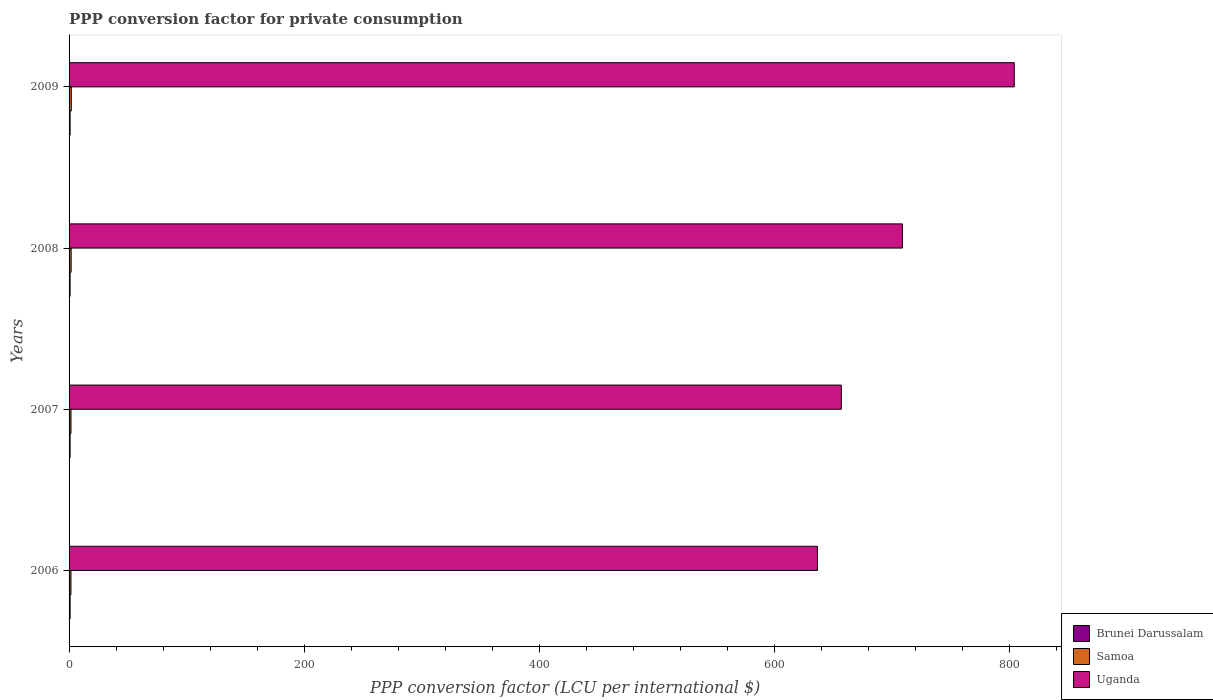How many different coloured bars are there?
Offer a very short reply. 3. Are the number of bars per tick equal to the number of legend labels?
Your answer should be very brief. Yes. How many bars are there on the 1st tick from the bottom?
Give a very brief answer. 3. What is the label of the 2nd group of bars from the top?
Your answer should be very brief. 2008. In how many cases, is the number of bars for a given year not equal to the number of legend labels?
Your answer should be compact. 0. What is the PPP conversion factor for private consumption in Uganda in 2006?
Give a very brief answer. 636.94. Across all years, what is the maximum PPP conversion factor for private consumption in Samoa?
Your response must be concise. 1.88. Across all years, what is the minimum PPP conversion factor for private consumption in Brunei Darussalam?
Ensure brevity in your answer.  0.86. In which year was the PPP conversion factor for private consumption in Samoa maximum?
Make the answer very short. 2009. In which year was the PPP conversion factor for private consumption in Samoa minimum?
Offer a very short reply. 2006. What is the total PPP conversion factor for private consumption in Brunei Darussalam in the graph?
Your response must be concise. 3.5. What is the difference between the PPP conversion factor for private consumption in Brunei Darussalam in 2006 and that in 2009?
Make the answer very short. 0.02. What is the difference between the PPP conversion factor for private consumption in Uganda in 2006 and the PPP conversion factor for private consumption in Brunei Darussalam in 2007?
Give a very brief answer. 636.06. What is the average PPP conversion factor for private consumption in Uganda per year?
Provide a succinct answer. 701.99. In the year 2009, what is the difference between the PPP conversion factor for private consumption in Uganda and PPP conversion factor for private consumption in Samoa?
Offer a very short reply. 802.58. What is the ratio of the PPP conversion factor for private consumption in Samoa in 2006 to that in 2009?
Offer a very short reply. 0.85. What is the difference between the highest and the second highest PPP conversion factor for private consumption in Uganda?
Ensure brevity in your answer.  95.19. What is the difference between the highest and the lowest PPP conversion factor for private consumption in Uganda?
Keep it short and to the point. 167.52. In how many years, is the PPP conversion factor for private consumption in Samoa greater than the average PPP conversion factor for private consumption in Samoa taken over all years?
Provide a short and direct response. 2. Is the sum of the PPP conversion factor for private consumption in Samoa in 2006 and 2008 greater than the maximum PPP conversion factor for private consumption in Uganda across all years?
Ensure brevity in your answer.  No. What does the 3rd bar from the top in 2007 represents?
Keep it short and to the point. Brunei Darussalam. What does the 1st bar from the bottom in 2008 represents?
Give a very brief answer. Brunei Darussalam. Is it the case that in every year, the sum of the PPP conversion factor for private consumption in Brunei Darussalam and PPP conversion factor for private consumption in Samoa is greater than the PPP conversion factor for private consumption in Uganda?
Keep it short and to the point. No. How many bars are there?
Your answer should be compact. 12. How many years are there in the graph?
Offer a very short reply. 4. What is the difference between two consecutive major ticks on the X-axis?
Make the answer very short. 200. Does the graph contain any zero values?
Your answer should be very brief. No. Where does the legend appear in the graph?
Give a very brief answer. Bottom right. How are the legend labels stacked?
Give a very brief answer. Vertical. What is the title of the graph?
Give a very brief answer. PPP conversion factor for private consumption. Does "Ethiopia" appear as one of the legend labels in the graph?
Make the answer very short. No. What is the label or title of the X-axis?
Make the answer very short. PPP conversion factor (LCU per international $). What is the label or title of the Y-axis?
Provide a succinct answer. Years. What is the PPP conversion factor (LCU per international $) in Brunei Darussalam in 2006?
Keep it short and to the point. 0.89. What is the PPP conversion factor (LCU per international $) in Samoa in 2006?
Give a very brief answer. 1.6. What is the PPP conversion factor (LCU per international $) in Uganda in 2006?
Ensure brevity in your answer.  636.94. What is the PPP conversion factor (LCU per international $) in Brunei Darussalam in 2007?
Your response must be concise. 0.88. What is the PPP conversion factor (LCU per international $) in Samoa in 2007?
Your answer should be compact. 1.64. What is the PPP conversion factor (LCU per international $) of Uganda in 2007?
Keep it short and to the point. 657.29. What is the PPP conversion factor (LCU per international $) in Brunei Darussalam in 2008?
Offer a terse response. 0.86. What is the PPP conversion factor (LCU per international $) in Samoa in 2008?
Your response must be concise. 1.76. What is the PPP conversion factor (LCU per international $) of Uganda in 2008?
Keep it short and to the point. 709.27. What is the PPP conversion factor (LCU per international $) in Brunei Darussalam in 2009?
Ensure brevity in your answer.  0.87. What is the PPP conversion factor (LCU per international $) of Samoa in 2009?
Your answer should be compact. 1.88. What is the PPP conversion factor (LCU per international $) in Uganda in 2009?
Give a very brief answer. 804.46. Across all years, what is the maximum PPP conversion factor (LCU per international $) in Brunei Darussalam?
Ensure brevity in your answer.  0.89. Across all years, what is the maximum PPP conversion factor (LCU per international $) of Samoa?
Your answer should be very brief. 1.88. Across all years, what is the maximum PPP conversion factor (LCU per international $) in Uganda?
Give a very brief answer. 804.46. Across all years, what is the minimum PPP conversion factor (LCU per international $) in Brunei Darussalam?
Your answer should be very brief. 0.86. Across all years, what is the minimum PPP conversion factor (LCU per international $) in Samoa?
Provide a succinct answer. 1.6. Across all years, what is the minimum PPP conversion factor (LCU per international $) of Uganda?
Your response must be concise. 636.94. What is the total PPP conversion factor (LCU per international $) of Brunei Darussalam in the graph?
Keep it short and to the point. 3.5. What is the total PPP conversion factor (LCU per international $) of Samoa in the graph?
Keep it short and to the point. 6.88. What is the total PPP conversion factor (LCU per international $) of Uganda in the graph?
Provide a short and direct response. 2807.96. What is the difference between the PPP conversion factor (LCU per international $) in Brunei Darussalam in 2006 and that in 2007?
Offer a terse response. 0.02. What is the difference between the PPP conversion factor (LCU per international $) in Samoa in 2006 and that in 2007?
Offer a very short reply. -0.04. What is the difference between the PPP conversion factor (LCU per international $) of Uganda in 2006 and that in 2007?
Your response must be concise. -20.35. What is the difference between the PPP conversion factor (LCU per international $) of Brunei Darussalam in 2006 and that in 2008?
Offer a very short reply. 0.03. What is the difference between the PPP conversion factor (LCU per international $) in Samoa in 2006 and that in 2008?
Your answer should be compact. -0.16. What is the difference between the PPP conversion factor (LCU per international $) of Uganda in 2006 and that in 2008?
Keep it short and to the point. -72.33. What is the difference between the PPP conversion factor (LCU per international $) in Brunei Darussalam in 2006 and that in 2009?
Your answer should be compact. 0.02. What is the difference between the PPP conversion factor (LCU per international $) of Samoa in 2006 and that in 2009?
Ensure brevity in your answer.  -0.28. What is the difference between the PPP conversion factor (LCU per international $) of Uganda in 2006 and that in 2009?
Offer a terse response. -167.52. What is the difference between the PPP conversion factor (LCU per international $) of Brunei Darussalam in 2007 and that in 2008?
Offer a very short reply. 0.01. What is the difference between the PPP conversion factor (LCU per international $) of Samoa in 2007 and that in 2008?
Keep it short and to the point. -0.12. What is the difference between the PPP conversion factor (LCU per international $) in Uganda in 2007 and that in 2008?
Your answer should be very brief. -51.98. What is the difference between the PPP conversion factor (LCU per international $) in Brunei Darussalam in 2007 and that in 2009?
Your answer should be very brief. 0. What is the difference between the PPP conversion factor (LCU per international $) in Samoa in 2007 and that in 2009?
Make the answer very short. -0.24. What is the difference between the PPP conversion factor (LCU per international $) in Uganda in 2007 and that in 2009?
Your answer should be compact. -147.17. What is the difference between the PPP conversion factor (LCU per international $) of Brunei Darussalam in 2008 and that in 2009?
Provide a succinct answer. -0.01. What is the difference between the PPP conversion factor (LCU per international $) of Samoa in 2008 and that in 2009?
Your response must be concise. -0.12. What is the difference between the PPP conversion factor (LCU per international $) of Uganda in 2008 and that in 2009?
Provide a succinct answer. -95.19. What is the difference between the PPP conversion factor (LCU per international $) of Brunei Darussalam in 2006 and the PPP conversion factor (LCU per international $) of Samoa in 2007?
Keep it short and to the point. -0.75. What is the difference between the PPP conversion factor (LCU per international $) in Brunei Darussalam in 2006 and the PPP conversion factor (LCU per international $) in Uganda in 2007?
Your response must be concise. -656.4. What is the difference between the PPP conversion factor (LCU per international $) in Samoa in 2006 and the PPP conversion factor (LCU per international $) in Uganda in 2007?
Provide a succinct answer. -655.69. What is the difference between the PPP conversion factor (LCU per international $) in Brunei Darussalam in 2006 and the PPP conversion factor (LCU per international $) in Samoa in 2008?
Offer a terse response. -0.87. What is the difference between the PPP conversion factor (LCU per international $) in Brunei Darussalam in 2006 and the PPP conversion factor (LCU per international $) in Uganda in 2008?
Offer a very short reply. -708.38. What is the difference between the PPP conversion factor (LCU per international $) of Samoa in 2006 and the PPP conversion factor (LCU per international $) of Uganda in 2008?
Keep it short and to the point. -707.67. What is the difference between the PPP conversion factor (LCU per international $) of Brunei Darussalam in 2006 and the PPP conversion factor (LCU per international $) of Samoa in 2009?
Your answer should be very brief. -0.99. What is the difference between the PPP conversion factor (LCU per international $) in Brunei Darussalam in 2006 and the PPP conversion factor (LCU per international $) in Uganda in 2009?
Offer a very short reply. -803.56. What is the difference between the PPP conversion factor (LCU per international $) of Samoa in 2006 and the PPP conversion factor (LCU per international $) of Uganda in 2009?
Provide a short and direct response. -802.86. What is the difference between the PPP conversion factor (LCU per international $) of Brunei Darussalam in 2007 and the PPP conversion factor (LCU per international $) of Samoa in 2008?
Keep it short and to the point. -0.89. What is the difference between the PPP conversion factor (LCU per international $) of Brunei Darussalam in 2007 and the PPP conversion factor (LCU per international $) of Uganda in 2008?
Your answer should be very brief. -708.39. What is the difference between the PPP conversion factor (LCU per international $) of Samoa in 2007 and the PPP conversion factor (LCU per international $) of Uganda in 2008?
Ensure brevity in your answer.  -707.63. What is the difference between the PPP conversion factor (LCU per international $) in Brunei Darussalam in 2007 and the PPP conversion factor (LCU per international $) in Samoa in 2009?
Your answer should be compact. -1. What is the difference between the PPP conversion factor (LCU per international $) of Brunei Darussalam in 2007 and the PPP conversion factor (LCU per international $) of Uganda in 2009?
Make the answer very short. -803.58. What is the difference between the PPP conversion factor (LCU per international $) of Samoa in 2007 and the PPP conversion factor (LCU per international $) of Uganda in 2009?
Offer a terse response. -802.82. What is the difference between the PPP conversion factor (LCU per international $) in Brunei Darussalam in 2008 and the PPP conversion factor (LCU per international $) in Samoa in 2009?
Offer a terse response. -1.02. What is the difference between the PPP conversion factor (LCU per international $) in Brunei Darussalam in 2008 and the PPP conversion factor (LCU per international $) in Uganda in 2009?
Ensure brevity in your answer.  -803.6. What is the difference between the PPP conversion factor (LCU per international $) in Samoa in 2008 and the PPP conversion factor (LCU per international $) in Uganda in 2009?
Offer a very short reply. -802.7. What is the average PPP conversion factor (LCU per international $) of Brunei Darussalam per year?
Your response must be concise. 0.88. What is the average PPP conversion factor (LCU per international $) of Samoa per year?
Ensure brevity in your answer.  1.72. What is the average PPP conversion factor (LCU per international $) of Uganda per year?
Offer a terse response. 701.99. In the year 2006, what is the difference between the PPP conversion factor (LCU per international $) in Brunei Darussalam and PPP conversion factor (LCU per international $) in Samoa?
Your response must be concise. -0.7. In the year 2006, what is the difference between the PPP conversion factor (LCU per international $) of Brunei Darussalam and PPP conversion factor (LCU per international $) of Uganda?
Your answer should be compact. -636.05. In the year 2006, what is the difference between the PPP conversion factor (LCU per international $) in Samoa and PPP conversion factor (LCU per international $) in Uganda?
Your answer should be very brief. -635.34. In the year 2007, what is the difference between the PPP conversion factor (LCU per international $) of Brunei Darussalam and PPP conversion factor (LCU per international $) of Samoa?
Your answer should be compact. -0.76. In the year 2007, what is the difference between the PPP conversion factor (LCU per international $) of Brunei Darussalam and PPP conversion factor (LCU per international $) of Uganda?
Your answer should be very brief. -656.41. In the year 2007, what is the difference between the PPP conversion factor (LCU per international $) in Samoa and PPP conversion factor (LCU per international $) in Uganda?
Offer a terse response. -655.65. In the year 2008, what is the difference between the PPP conversion factor (LCU per international $) of Brunei Darussalam and PPP conversion factor (LCU per international $) of Samoa?
Your answer should be very brief. -0.9. In the year 2008, what is the difference between the PPP conversion factor (LCU per international $) of Brunei Darussalam and PPP conversion factor (LCU per international $) of Uganda?
Give a very brief answer. -708.41. In the year 2008, what is the difference between the PPP conversion factor (LCU per international $) in Samoa and PPP conversion factor (LCU per international $) in Uganda?
Keep it short and to the point. -707.51. In the year 2009, what is the difference between the PPP conversion factor (LCU per international $) of Brunei Darussalam and PPP conversion factor (LCU per international $) of Samoa?
Give a very brief answer. -1.01. In the year 2009, what is the difference between the PPP conversion factor (LCU per international $) of Brunei Darussalam and PPP conversion factor (LCU per international $) of Uganda?
Make the answer very short. -803.58. In the year 2009, what is the difference between the PPP conversion factor (LCU per international $) in Samoa and PPP conversion factor (LCU per international $) in Uganda?
Make the answer very short. -802.58. What is the ratio of the PPP conversion factor (LCU per international $) in Brunei Darussalam in 2006 to that in 2007?
Your answer should be compact. 1.02. What is the ratio of the PPP conversion factor (LCU per international $) in Samoa in 2006 to that in 2007?
Provide a succinct answer. 0.97. What is the ratio of the PPP conversion factor (LCU per international $) in Uganda in 2006 to that in 2007?
Keep it short and to the point. 0.97. What is the ratio of the PPP conversion factor (LCU per international $) of Brunei Darussalam in 2006 to that in 2008?
Offer a very short reply. 1.04. What is the ratio of the PPP conversion factor (LCU per international $) in Samoa in 2006 to that in 2008?
Your answer should be compact. 0.91. What is the ratio of the PPP conversion factor (LCU per international $) of Uganda in 2006 to that in 2008?
Make the answer very short. 0.9. What is the ratio of the PPP conversion factor (LCU per international $) in Brunei Darussalam in 2006 to that in 2009?
Keep it short and to the point. 1.02. What is the ratio of the PPP conversion factor (LCU per international $) in Samoa in 2006 to that in 2009?
Provide a short and direct response. 0.85. What is the ratio of the PPP conversion factor (LCU per international $) in Uganda in 2006 to that in 2009?
Ensure brevity in your answer.  0.79. What is the ratio of the PPP conversion factor (LCU per international $) of Brunei Darussalam in 2007 to that in 2008?
Keep it short and to the point. 1.02. What is the ratio of the PPP conversion factor (LCU per international $) of Samoa in 2007 to that in 2008?
Ensure brevity in your answer.  0.93. What is the ratio of the PPP conversion factor (LCU per international $) of Uganda in 2007 to that in 2008?
Your response must be concise. 0.93. What is the ratio of the PPP conversion factor (LCU per international $) in Samoa in 2007 to that in 2009?
Your response must be concise. 0.87. What is the ratio of the PPP conversion factor (LCU per international $) in Uganda in 2007 to that in 2009?
Your answer should be very brief. 0.82. What is the ratio of the PPP conversion factor (LCU per international $) in Brunei Darussalam in 2008 to that in 2009?
Ensure brevity in your answer.  0.99. What is the ratio of the PPP conversion factor (LCU per international $) of Samoa in 2008 to that in 2009?
Your response must be concise. 0.94. What is the ratio of the PPP conversion factor (LCU per international $) of Uganda in 2008 to that in 2009?
Provide a succinct answer. 0.88. What is the difference between the highest and the second highest PPP conversion factor (LCU per international $) of Brunei Darussalam?
Your answer should be very brief. 0.02. What is the difference between the highest and the second highest PPP conversion factor (LCU per international $) of Samoa?
Make the answer very short. 0.12. What is the difference between the highest and the second highest PPP conversion factor (LCU per international $) in Uganda?
Give a very brief answer. 95.19. What is the difference between the highest and the lowest PPP conversion factor (LCU per international $) of Brunei Darussalam?
Provide a short and direct response. 0.03. What is the difference between the highest and the lowest PPP conversion factor (LCU per international $) of Samoa?
Offer a very short reply. 0.28. What is the difference between the highest and the lowest PPP conversion factor (LCU per international $) of Uganda?
Offer a terse response. 167.52. 